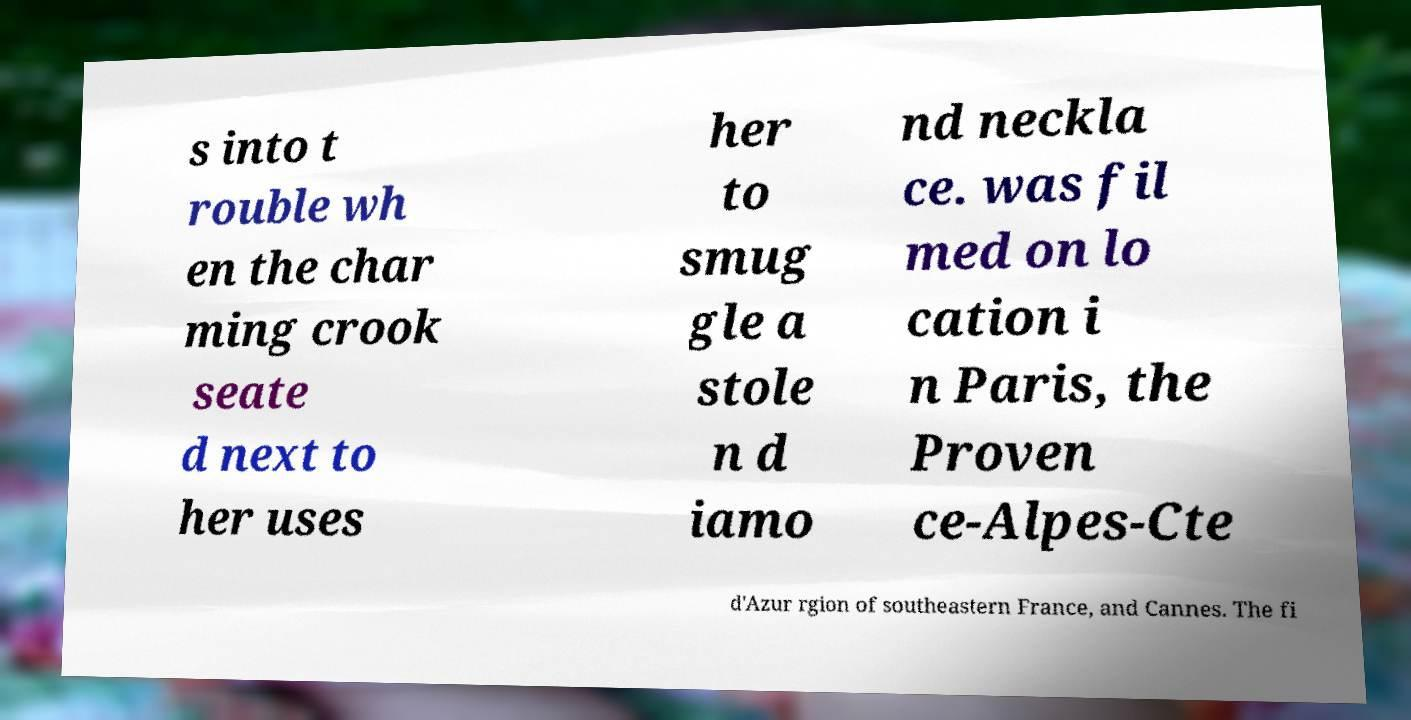Please read and relay the text visible in this image. What does it say? s into t rouble wh en the char ming crook seate d next to her uses her to smug gle a stole n d iamo nd neckla ce. was fil med on lo cation i n Paris, the Proven ce-Alpes-Cte d'Azur rgion of southeastern France, and Cannes. The fi 